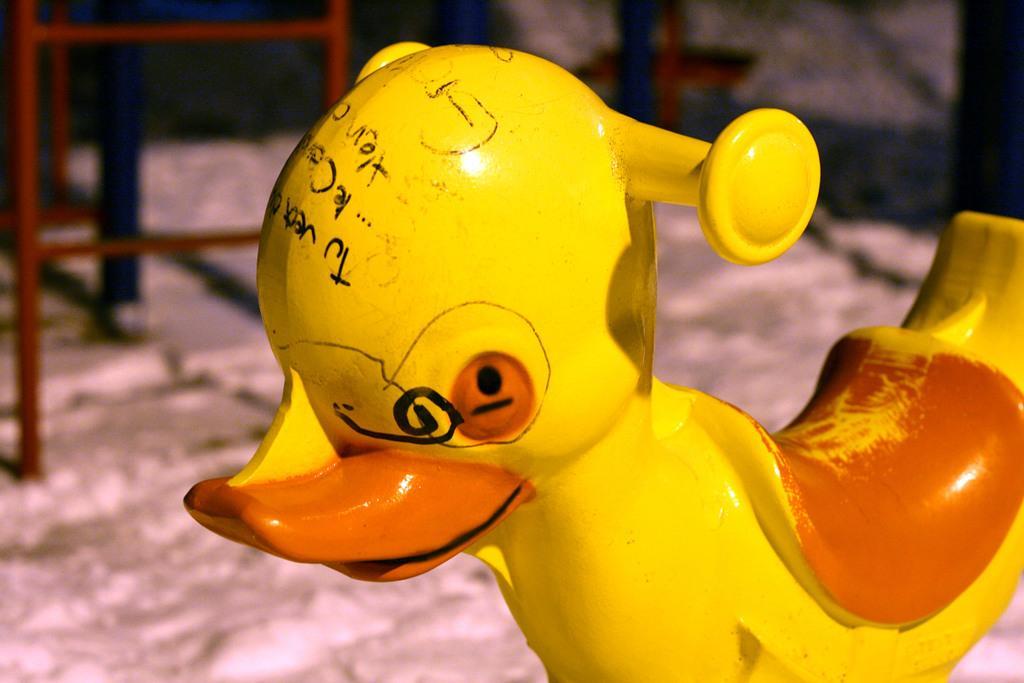Describe this image in one or two sentences. In the center of the image there is a toy on the ground. In the background we can see chair and wall. 